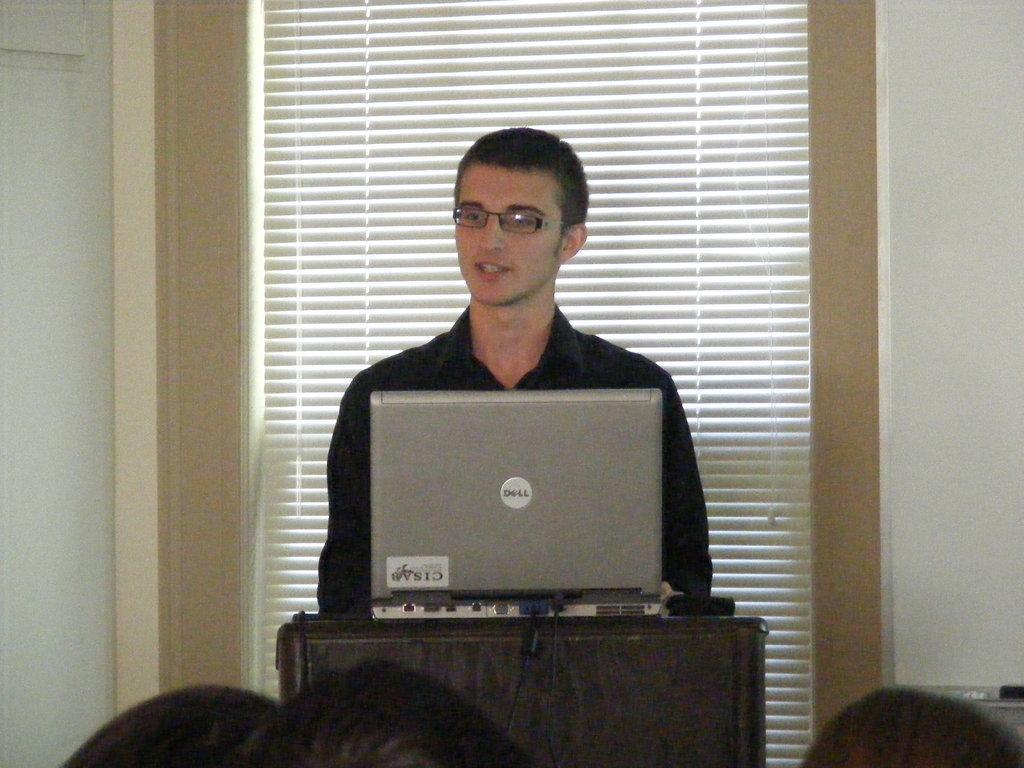Could you give a brief overview of what you see in this image? In the center of the image a man is standing in-front of podium. We can see a laptop is present on the podium. In the background of the image wall is there. At the bottom of the image some persons are there. 